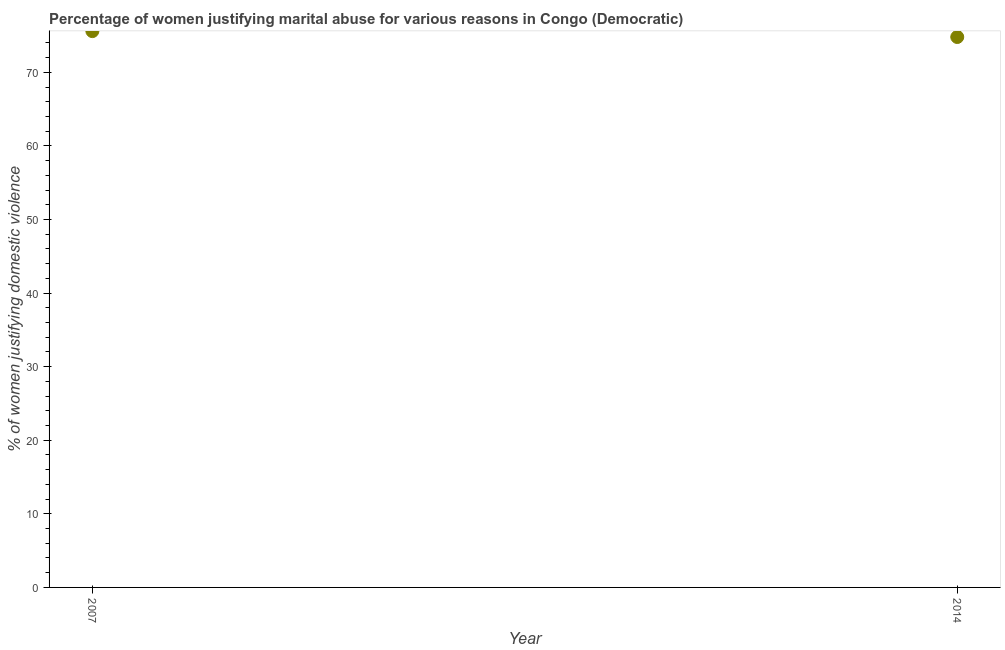What is the percentage of women justifying marital abuse in 2007?
Ensure brevity in your answer.  75.6. Across all years, what is the maximum percentage of women justifying marital abuse?
Your response must be concise. 75.6. Across all years, what is the minimum percentage of women justifying marital abuse?
Your response must be concise. 74.8. In which year was the percentage of women justifying marital abuse minimum?
Offer a very short reply. 2014. What is the sum of the percentage of women justifying marital abuse?
Your answer should be very brief. 150.4. What is the difference between the percentage of women justifying marital abuse in 2007 and 2014?
Offer a terse response. 0.8. What is the average percentage of women justifying marital abuse per year?
Give a very brief answer. 75.2. What is the median percentage of women justifying marital abuse?
Provide a short and direct response. 75.2. In how many years, is the percentage of women justifying marital abuse greater than 14 %?
Make the answer very short. 2. Do a majority of the years between 2007 and 2014 (inclusive) have percentage of women justifying marital abuse greater than 2 %?
Your response must be concise. Yes. What is the ratio of the percentage of women justifying marital abuse in 2007 to that in 2014?
Your answer should be compact. 1.01. Is the percentage of women justifying marital abuse in 2007 less than that in 2014?
Offer a very short reply. No. In how many years, is the percentage of women justifying marital abuse greater than the average percentage of women justifying marital abuse taken over all years?
Ensure brevity in your answer.  1. How many years are there in the graph?
Make the answer very short. 2. What is the difference between two consecutive major ticks on the Y-axis?
Provide a short and direct response. 10. Does the graph contain any zero values?
Your answer should be very brief. No. Does the graph contain grids?
Your answer should be very brief. No. What is the title of the graph?
Provide a succinct answer. Percentage of women justifying marital abuse for various reasons in Congo (Democratic). What is the label or title of the X-axis?
Your answer should be very brief. Year. What is the label or title of the Y-axis?
Your answer should be very brief. % of women justifying domestic violence. What is the % of women justifying domestic violence in 2007?
Ensure brevity in your answer.  75.6. What is the % of women justifying domestic violence in 2014?
Provide a short and direct response. 74.8. What is the difference between the % of women justifying domestic violence in 2007 and 2014?
Provide a succinct answer. 0.8. 